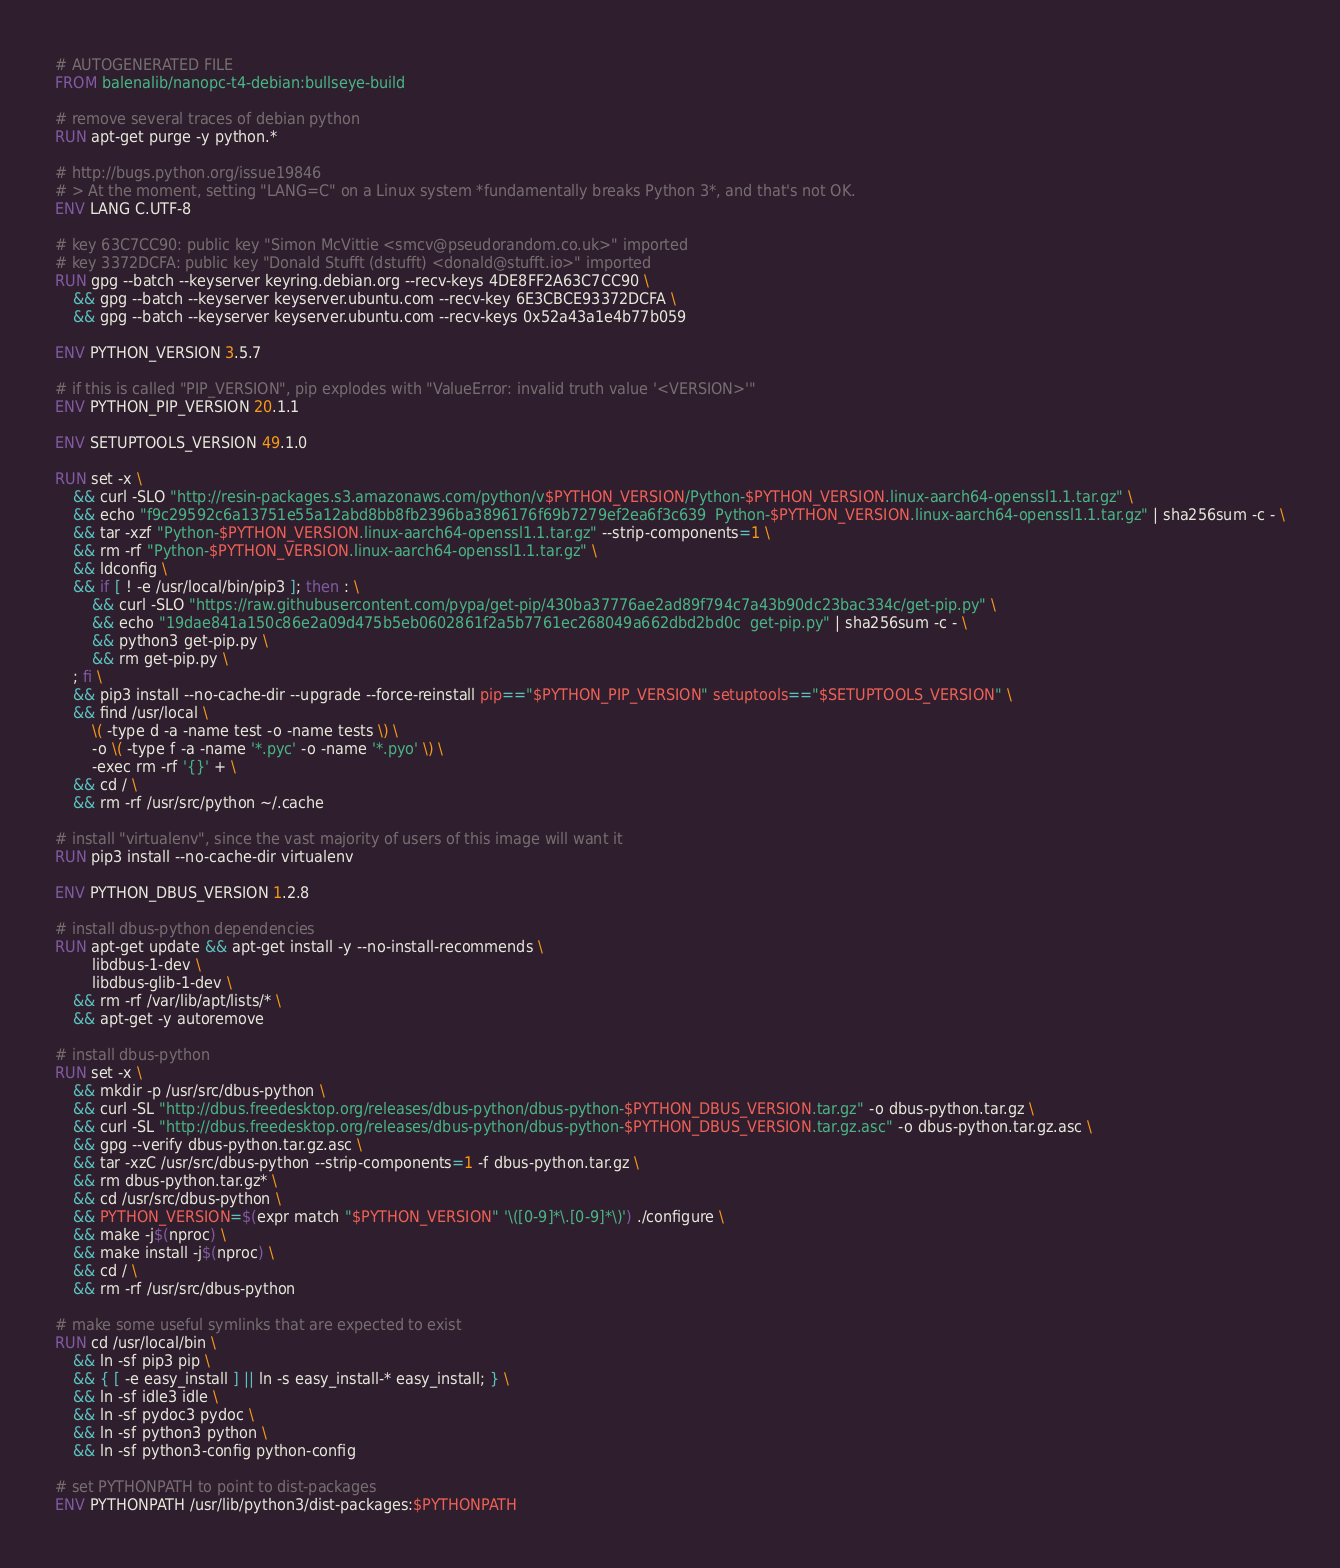<code> <loc_0><loc_0><loc_500><loc_500><_Dockerfile_># AUTOGENERATED FILE
FROM balenalib/nanopc-t4-debian:bullseye-build

# remove several traces of debian python
RUN apt-get purge -y python.*

# http://bugs.python.org/issue19846
# > At the moment, setting "LANG=C" on a Linux system *fundamentally breaks Python 3*, and that's not OK.
ENV LANG C.UTF-8

# key 63C7CC90: public key "Simon McVittie <smcv@pseudorandom.co.uk>" imported
# key 3372DCFA: public key "Donald Stufft (dstufft) <donald@stufft.io>" imported
RUN gpg --batch --keyserver keyring.debian.org --recv-keys 4DE8FF2A63C7CC90 \
	&& gpg --batch --keyserver keyserver.ubuntu.com --recv-key 6E3CBCE93372DCFA \
	&& gpg --batch --keyserver keyserver.ubuntu.com --recv-keys 0x52a43a1e4b77b059

ENV PYTHON_VERSION 3.5.7

# if this is called "PIP_VERSION", pip explodes with "ValueError: invalid truth value '<VERSION>'"
ENV PYTHON_PIP_VERSION 20.1.1

ENV SETUPTOOLS_VERSION 49.1.0

RUN set -x \
	&& curl -SLO "http://resin-packages.s3.amazonaws.com/python/v$PYTHON_VERSION/Python-$PYTHON_VERSION.linux-aarch64-openssl1.1.tar.gz" \
	&& echo "f9c29592c6a13751e55a12abd8bb8fb2396ba3896176f69b7279ef2ea6f3c639  Python-$PYTHON_VERSION.linux-aarch64-openssl1.1.tar.gz" | sha256sum -c - \
	&& tar -xzf "Python-$PYTHON_VERSION.linux-aarch64-openssl1.1.tar.gz" --strip-components=1 \
	&& rm -rf "Python-$PYTHON_VERSION.linux-aarch64-openssl1.1.tar.gz" \
	&& ldconfig \
	&& if [ ! -e /usr/local/bin/pip3 ]; then : \
		&& curl -SLO "https://raw.githubusercontent.com/pypa/get-pip/430ba37776ae2ad89f794c7a43b90dc23bac334c/get-pip.py" \
		&& echo "19dae841a150c86e2a09d475b5eb0602861f2a5b7761ec268049a662dbd2bd0c  get-pip.py" | sha256sum -c - \
		&& python3 get-pip.py \
		&& rm get-pip.py \
	; fi \
	&& pip3 install --no-cache-dir --upgrade --force-reinstall pip=="$PYTHON_PIP_VERSION" setuptools=="$SETUPTOOLS_VERSION" \
	&& find /usr/local \
		\( -type d -a -name test -o -name tests \) \
		-o \( -type f -a -name '*.pyc' -o -name '*.pyo' \) \
		-exec rm -rf '{}' + \
	&& cd / \
	&& rm -rf /usr/src/python ~/.cache

# install "virtualenv", since the vast majority of users of this image will want it
RUN pip3 install --no-cache-dir virtualenv

ENV PYTHON_DBUS_VERSION 1.2.8

# install dbus-python dependencies 
RUN apt-get update && apt-get install -y --no-install-recommends \
		libdbus-1-dev \
		libdbus-glib-1-dev \
	&& rm -rf /var/lib/apt/lists/* \
	&& apt-get -y autoremove

# install dbus-python
RUN set -x \
	&& mkdir -p /usr/src/dbus-python \
	&& curl -SL "http://dbus.freedesktop.org/releases/dbus-python/dbus-python-$PYTHON_DBUS_VERSION.tar.gz" -o dbus-python.tar.gz \
	&& curl -SL "http://dbus.freedesktop.org/releases/dbus-python/dbus-python-$PYTHON_DBUS_VERSION.tar.gz.asc" -o dbus-python.tar.gz.asc \
	&& gpg --verify dbus-python.tar.gz.asc \
	&& tar -xzC /usr/src/dbus-python --strip-components=1 -f dbus-python.tar.gz \
	&& rm dbus-python.tar.gz* \
	&& cd /usr/src/dbus-python \
	&& PYTHON_VERSION=$(expr match "$PYTHON_VERSION" '\([0-9]*\.[0-9]*\)') ./configure \
	&& make -j$(nproc) \
	&& make install -j$(nproc) \
	&& cd / \
	&& rm -rf /usr/src/dbus-python

# make some useful symlinks that are expected to exist
RUN cd /usr/local/bin \
	&& ln -sf pip3 pip \
	&& { [ -e easy_install ] || ln -s easy_install-* easy_install; } \
	&& ln -sf idle3 idle \
	&& ln -sf pydoc3 pydoc \
	&& ln -sf python3 python \
	&& ln -sf python3-config python-config

# set PYTHONPATH to point to dist-packages
ENV PYTHONPATH /usr/lib/python3/dist-packages:$PYTHONPATH
</code> 